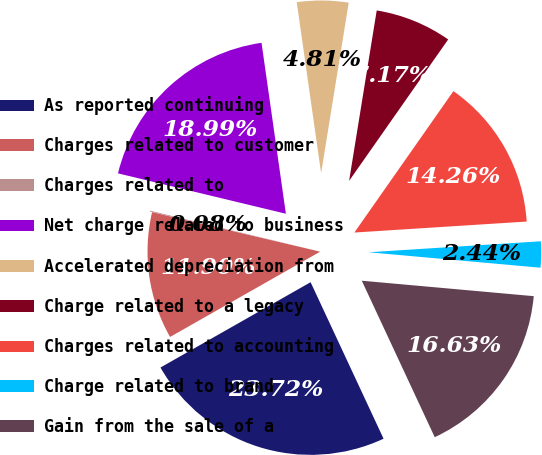Convert chart. <chart><loc_0><loc_0><loc_500><loc_500><pie_chart><fcel>As reported continuing<fcel>Charges related to customer<fcel>Charges related to<fcel>Net charge related to business<fcel>Accelerated depreciation from<fcel>Charge related to a legacy<fcel>Charges related to accounting<fcel>Charge related to brand<fcel>Gain from the sale of a<nl><fcel>23.72%<fcel>11.9%<fcel>0.08%<fcel>18.99%<fcel>4.81%<fcel>7.17%<fcel>14.26%<fcel>2.44%<fcel>16.63%<nl></chart> 